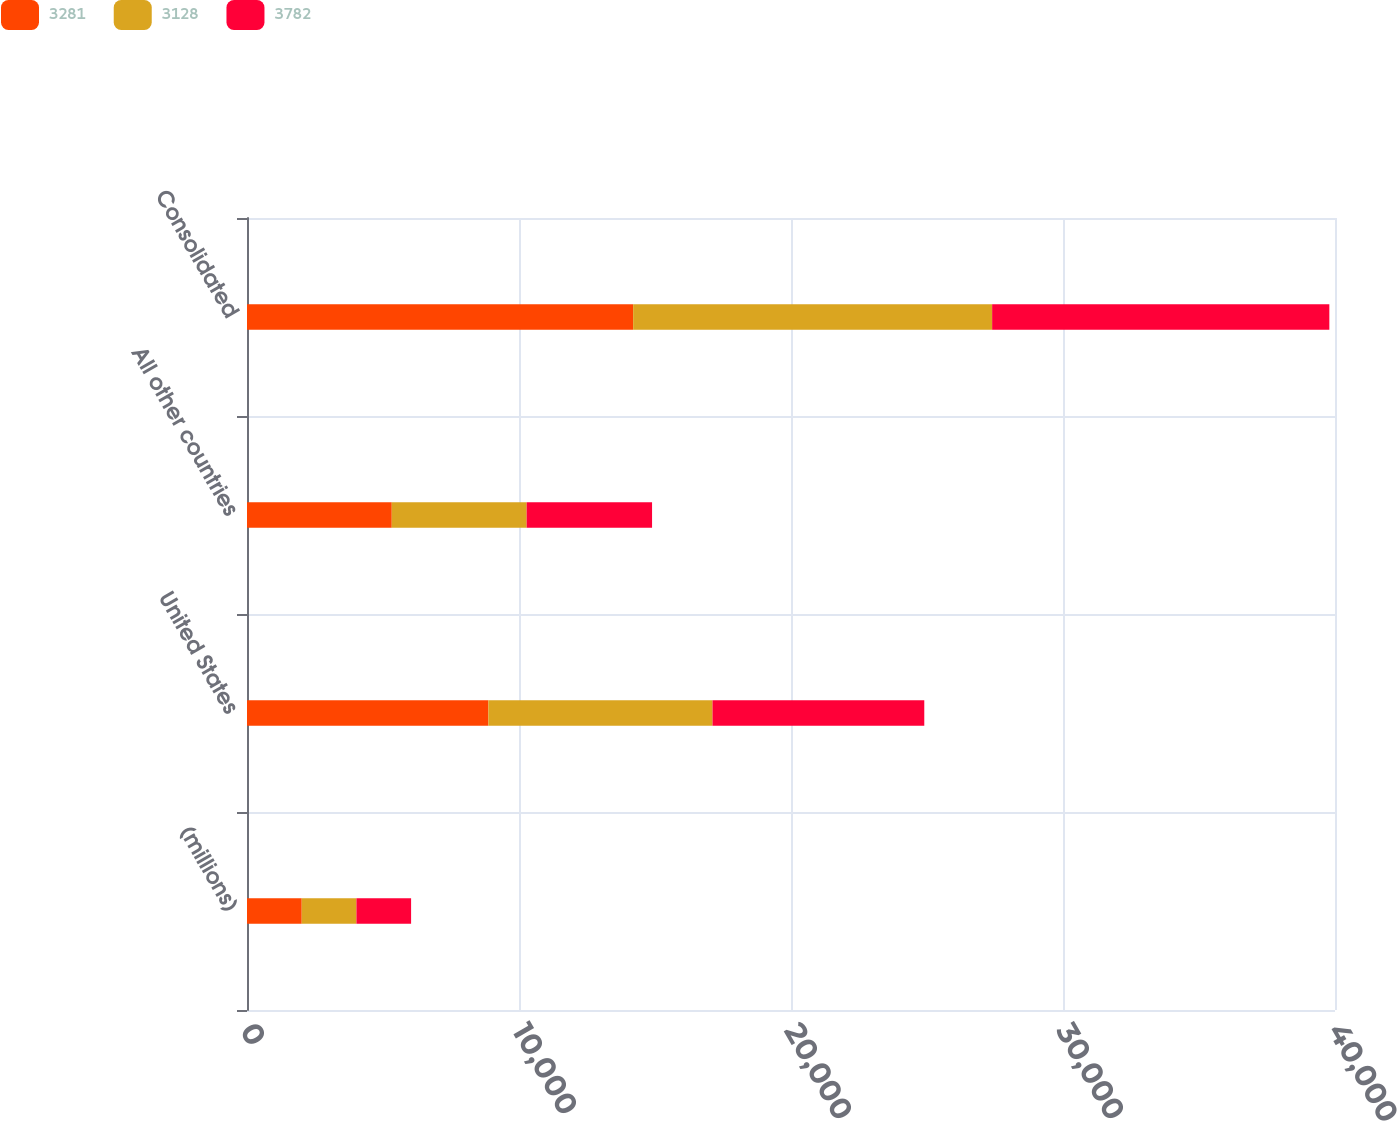Convert chart. <chart><loc_0><loc_0><loc_500><loc_500><stacked_bar_chart><ecel><fcel>(millions)<fcel>United States<fcel>All other countries<fcel>Consolidated<nl><fcel>3281<fcel>2012<fcel>8875<fcel>5322<fcel>14197<nl><fcel>3128<fcel>2011<fcel>8239<fcel>4959<fcel>13198<nl><fcel>3782<fcel>2010<fcel>7786<fcel>4611<fcel>12397<nl></chart> 